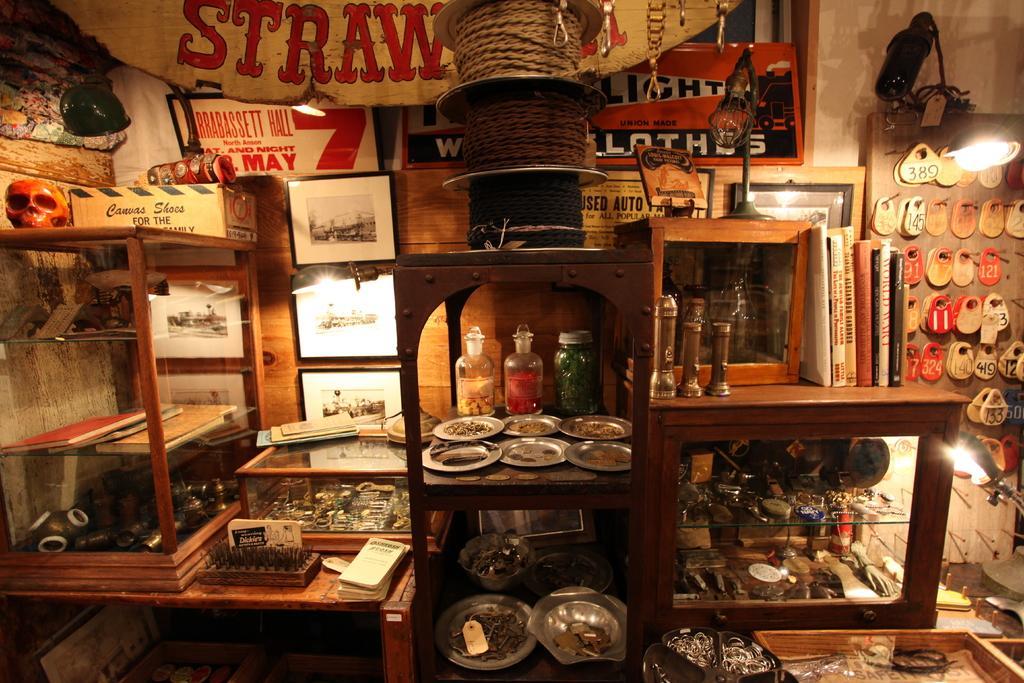How would you summarize this image in a sentence or two? there are so many things on a shelf arranged in rows. 